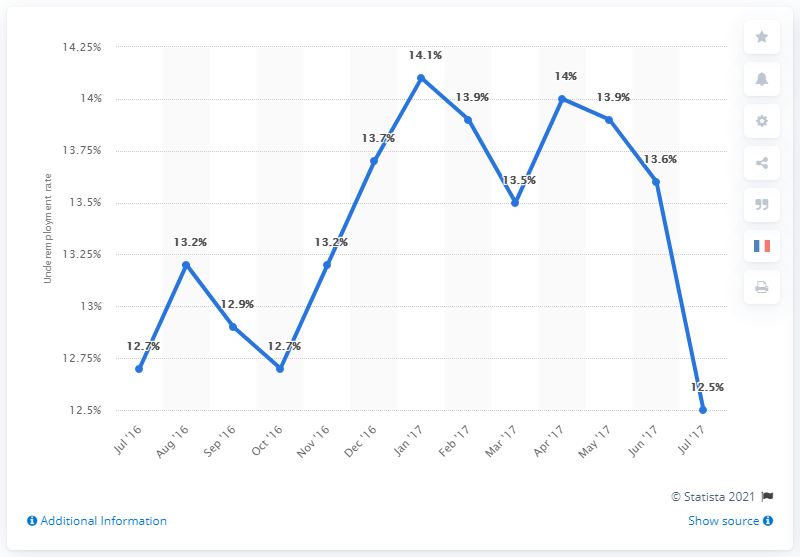Point out several critical features in this image. In July 2017, the underemployment rate in the United States was 12.5%. 